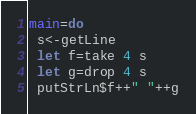<code> <loc_0><loc_0><loc_500><loc_500><_Haskell_>main=do
 s<-getLine
 let f=take 4 s
 let g=drop 4 s
 putStrLn$f++" "++g</code> 